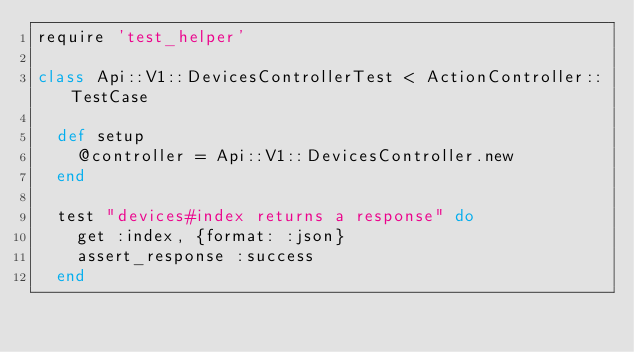Convert code to text. <code><loc_0><loc_0><loc_500><loc_500><_Ruby_>require 'test_helper'

class Api::V1::DevicesControllerTest < ActionController::TestCase
  
  def setup
    @controller = Api::V1::DevicesController.new
  end

  test "devices#index returns a response" do
    get :index, {format: :json}
    assert_response :success
  end
</code> 